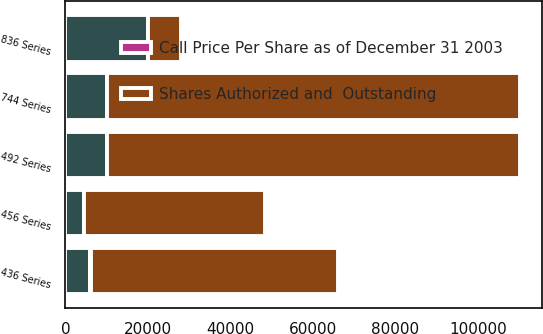Convert chart. <chart><loc_0><loc_0><loc_500><loc_500><stacked_bar_chart><ecel><fcel>436 Series<fcel>456 Series<fcel>492 Series<fcel>744 Series<fcel>836 Series<nl><fcel>Shares Authorized and  Outstanding<fcel>59920<fcel>43887<fcel>100000<fcel>100000<fcel>7996<nl><fcel>nan<fcel>5992<fcel>4389<fcel>10000<fcel>10000<fcel>20000<nl><fcel>Call Price Per Share as of December 31 2003<fcel>103.86<fcel>107<fcel>102.88<fcel>102.81<fcel>100<nl></chart> 